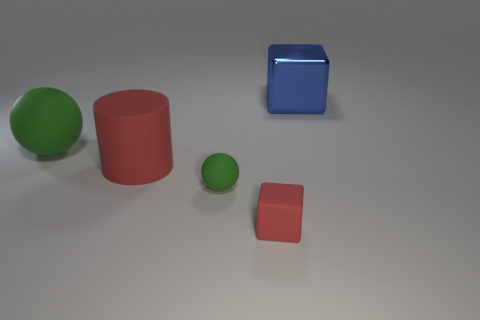What can you infer about the material of the objects based on their appearance? Based on their appearances, the blue object appears to resemble glass or polished metal, while the red and green objects seem to be made of a plastic or rubber-like material. 